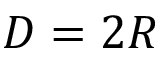Convert formula to latex. <formula><loc_0><loc_0><loc_500><loc_500>D = 2 R</formula> 